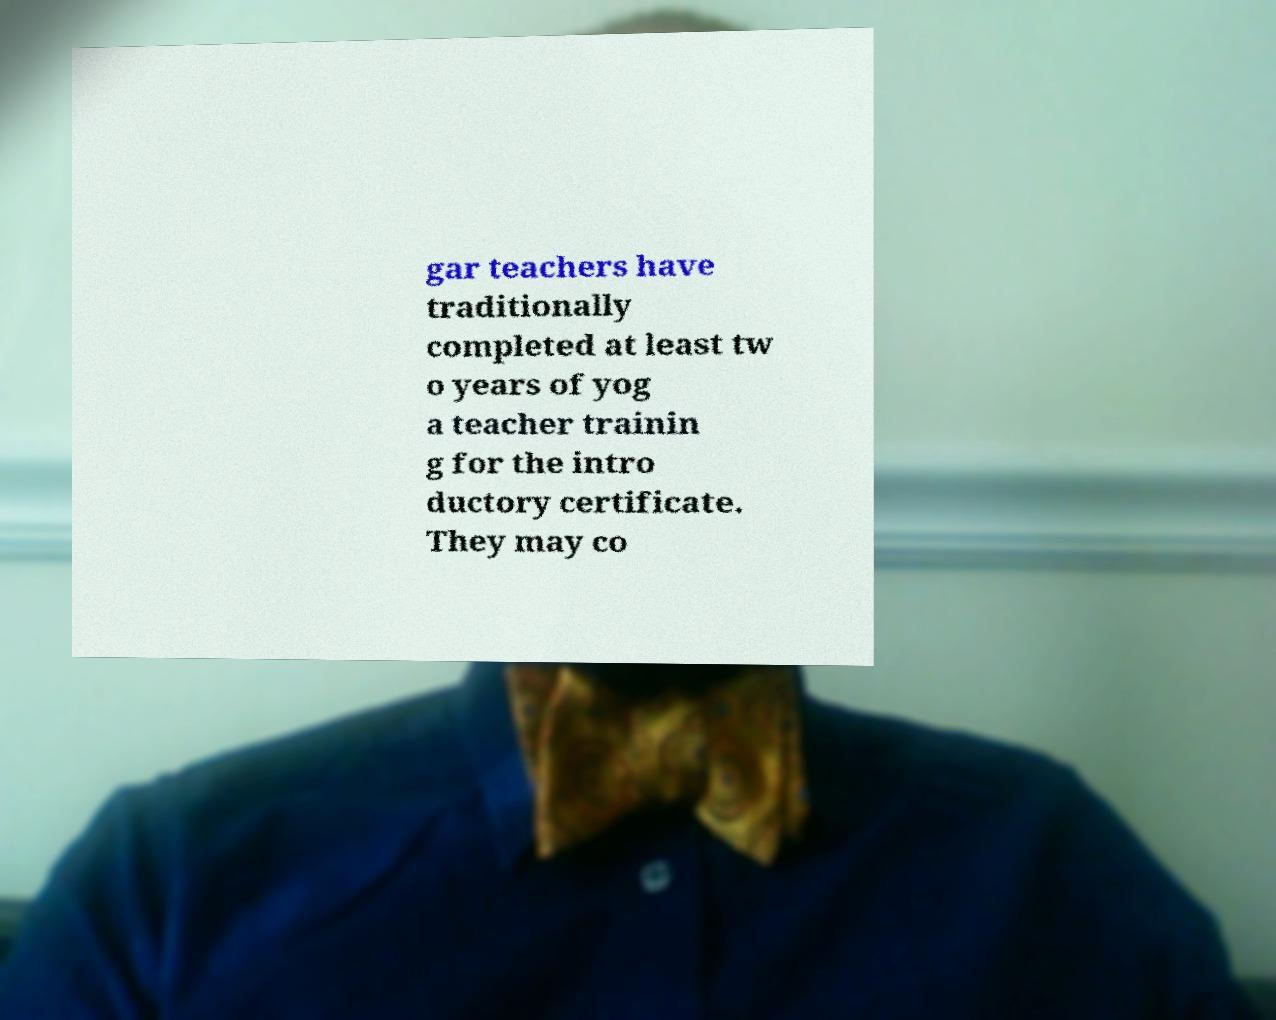Can you read and provide the text displayed in the image?This photo seems to have some interesting text. Can you extract and type it out for me? gar teachers have traditionally completed at least tw o years of yog a teacher trainin g for the intro ductory certificate. They may co 